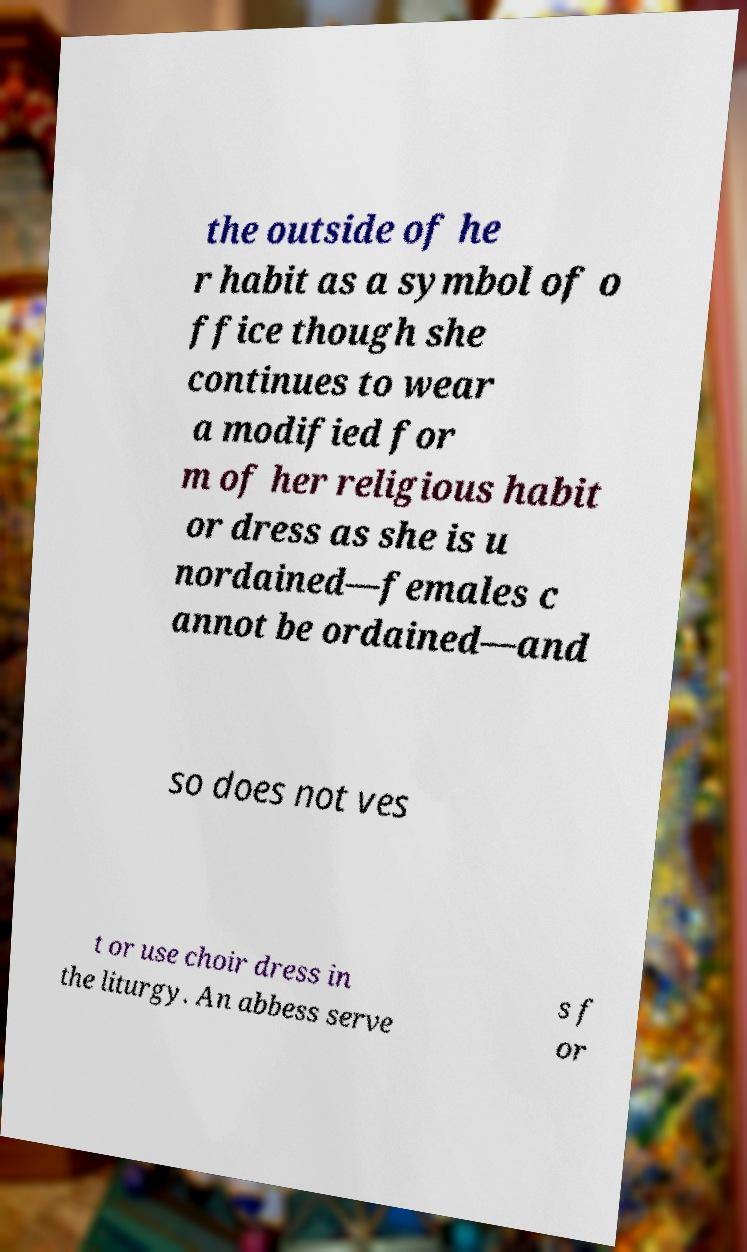Please identify and transcribe the text found in this image. the outside of he r habit as a symbol of o ffice though she continues to wear a modified for m of her religious habit or dress as she is u nordained—females c annot be ordained—and so does not ves t or use choir dress in the liturgy. An abbess serve s f or 